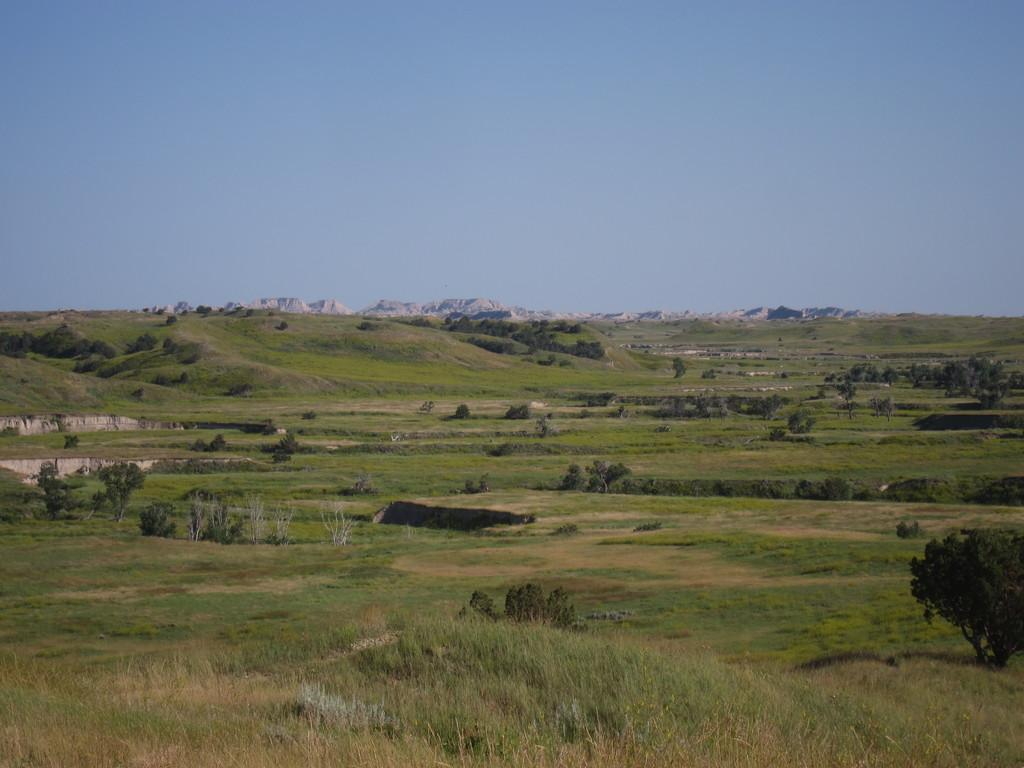What type of environment is depicted in the image? The image is an outside view. What can be seen on the ground in the image? There is grass and trees on the ground in the image. What is visible in the background of the image? There are hills visible in the background of the image. What is visible at the top of the image? The sky is visible at the top of the image. What type of guitar can be seen being played in the image? There is no guitar present in the image; it is an outside view with grass, trees, hills, and the sky. What emotion is displayed by the trees in the image? Trees do not display emotions, so it is not possible to determine an emotion like disgust from the image. 